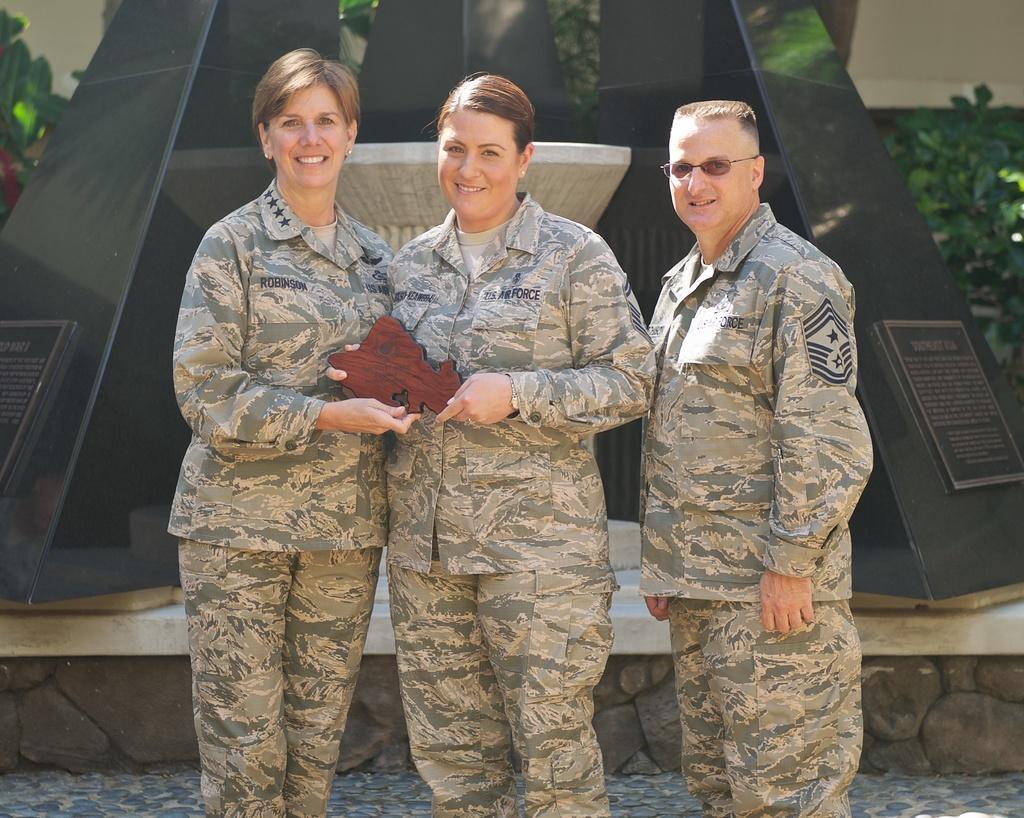In one or two sentences, can you explain what this image depicts? In this picture we can see there are three people standing and two people holding an object. Behind the people there are black pillars, plants and the wall. 